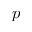<formula> <loc_0><loc_0><loc_500><loc_500>p</formula> 